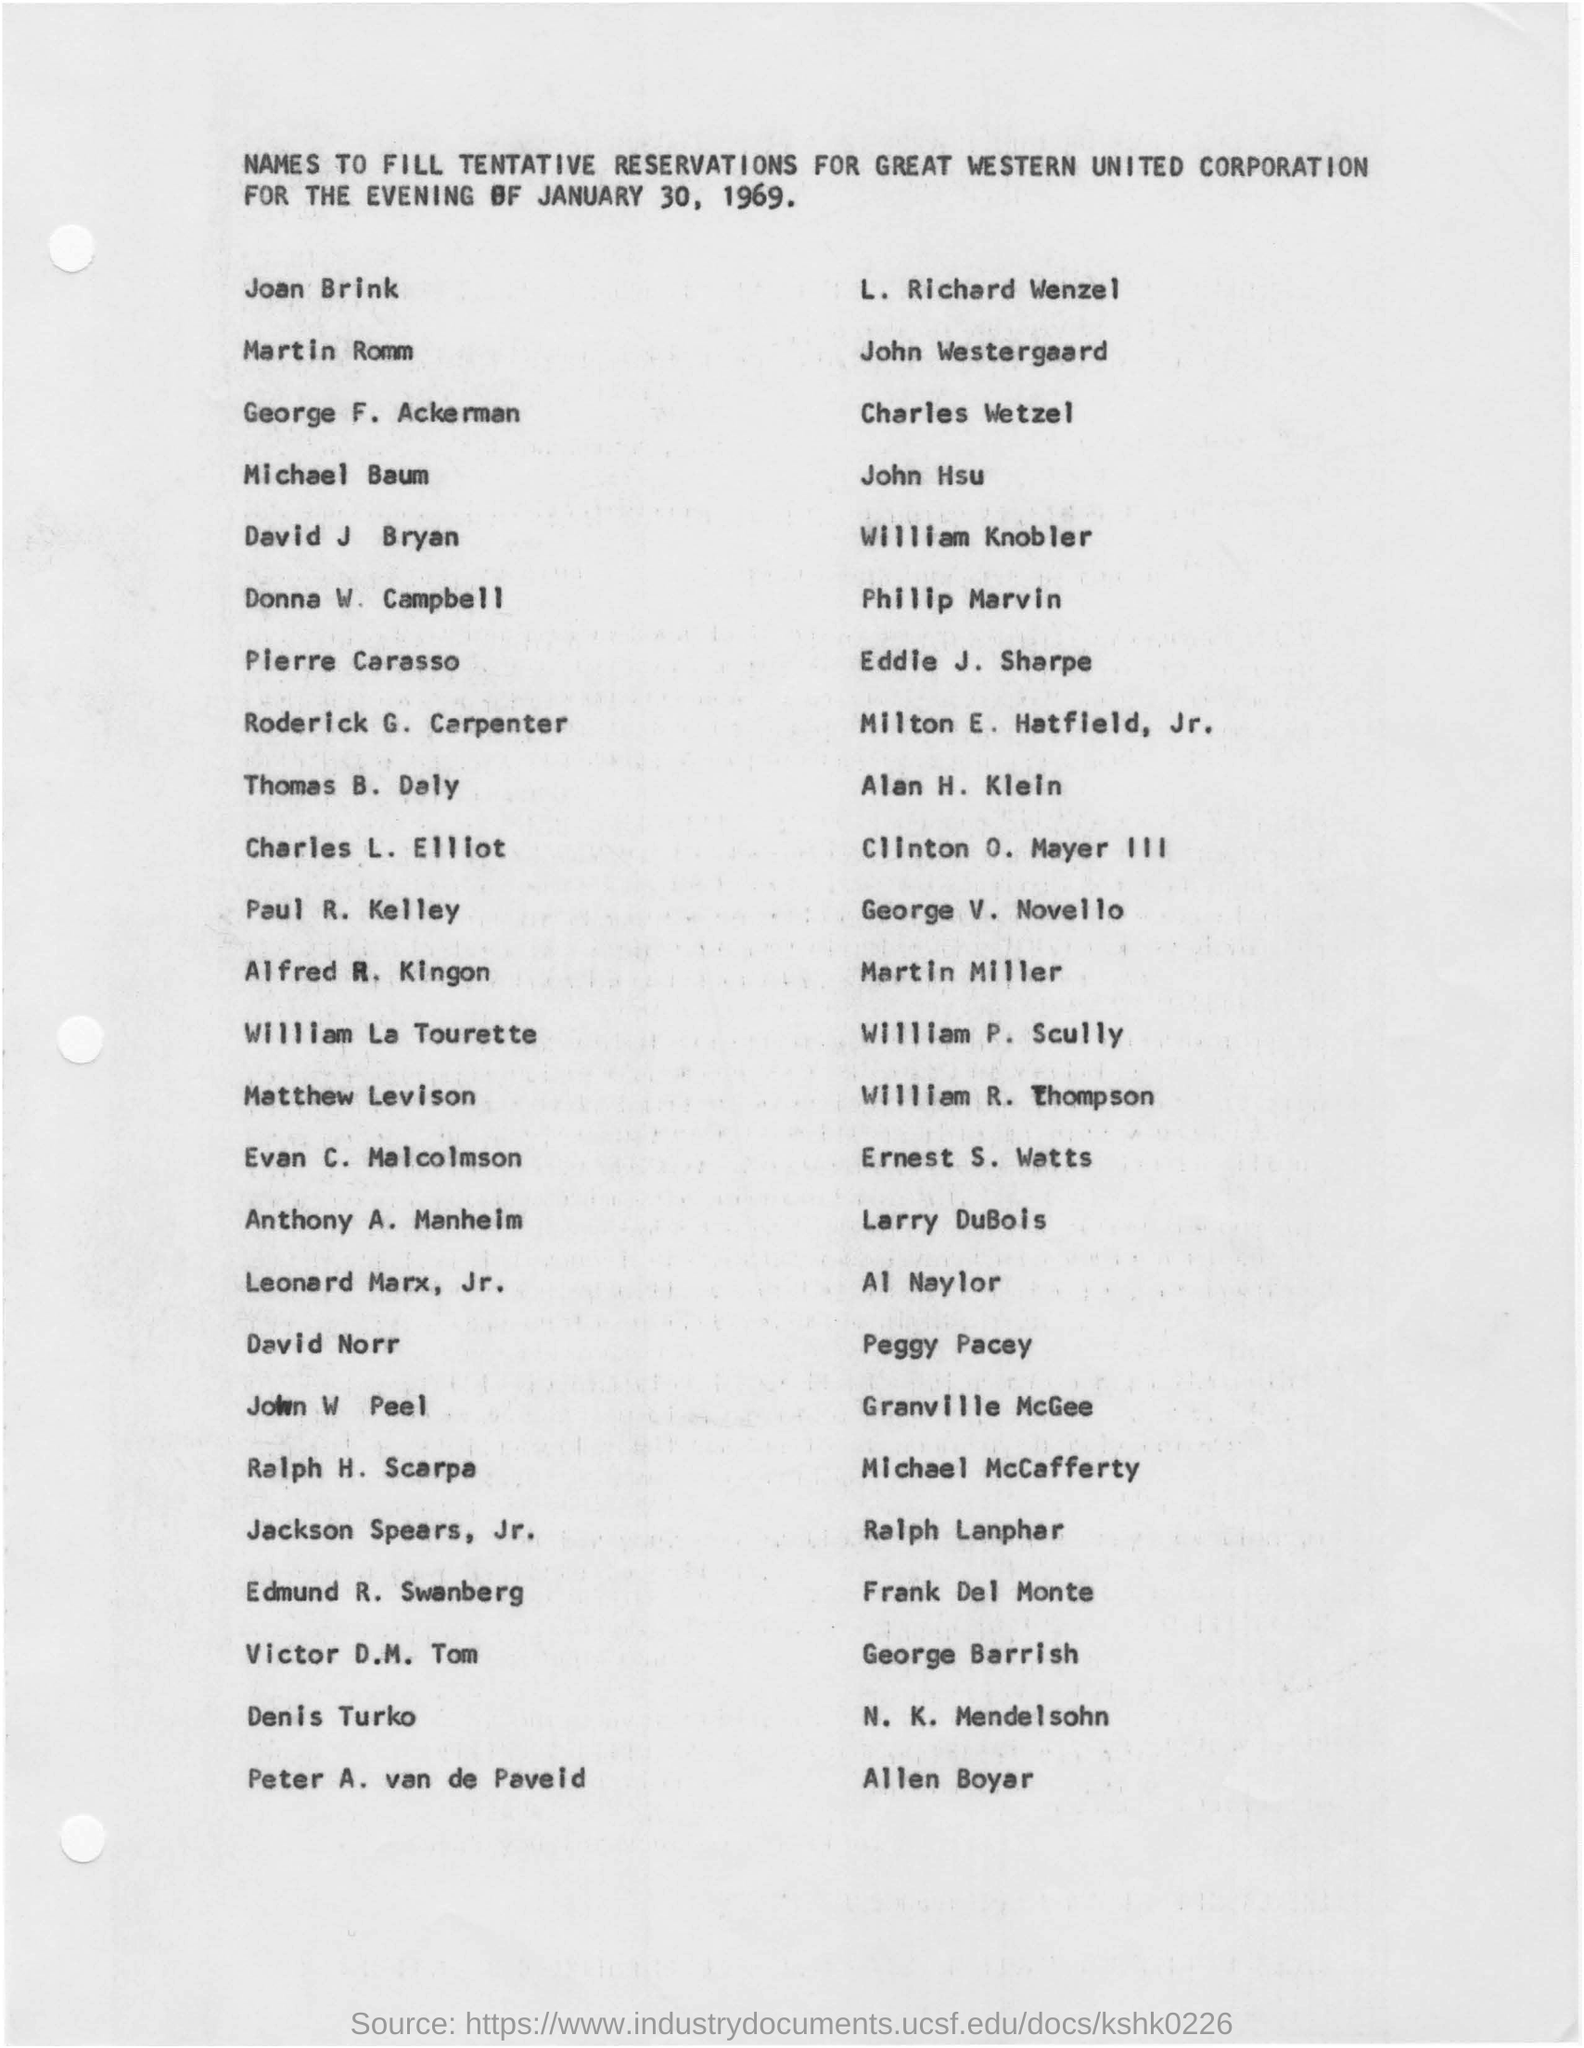Specify some key components in this picture. On January 30, 1969, the tentative reservation was made. The purpose of the tentative reservations made by Great Western United Corporation for the evening of January 30, 1969, was to reserve space and facilities for the evening. 